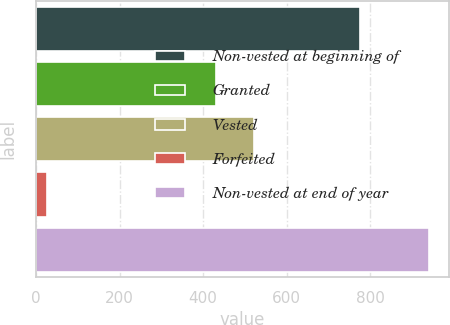Convert chart. <chart><loc_0><loc_0><loc_500><loc_500><bar_chart><fcel>Non-vested at beginning of<fcel>Granted<fcel>Vested<fcel>Forfeited<fcel>Non-vested at end of year<nl><fcel>775<fcel>430<fcel>521.4<fcel>27<fcel>941<nl></chart> 